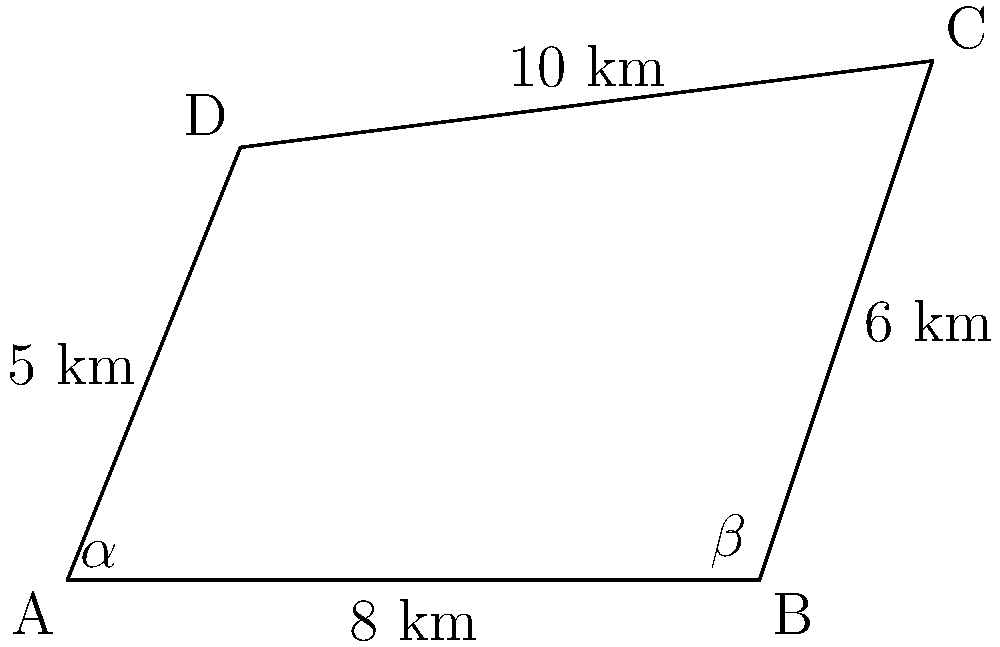Imagine you're scouting locations for the next big Irish drama series, and you've found a perfect field for a crucial scene. The field is shaped like an irregular quadrilateral ABCD, as shown in the diagram. The lengths of the sides are: AB = 8 km, BC = 6 km, CD = 10 km, and DA = 5 km. The angles at vertices A and B are $\alpha$ and $\beta$ respectively. If $\alpha = 60°$ and $\beta = 120°$, what is the area of the field in square kilometers? Let's solve this step-by-step using trigonometric formulas:

1) We can divide the quadrilateral into two triangles: ABC and ACD.

2) For triangle ABC:
   - We know two sides (AB = 8 km, BC = 6 km) and the included angle ($\beta = 120°$).
   - Area of ABC = $\frac{1}{2} \cdot AB \cdot BC \cdot \sin(\beta)$
   - Area of ABC = $\frac{1}{2} \cdot 8 \cdot 6 \cdot \sin(120°) = 24 \cdot \frac{\sqrt{3}}{2} = 12\sqrt{3}$ km²

3) For triangle ACD:
   - We know two sides (CD = 10 km, DA = 5 km) and the angle at A ($\alpha = 60°$).
   - Area of ACD = $\frac{1}{2} \cdot CD \cdot DA \cdot \sin(\alpha)$
   - Area of ACD = $\frac{1}{2} \cdot 10 \cdot 5 \cdot \sin(60°) = 25 \cdot \frac{\sqrt{3}}{2} = \frac{25\sqrt{3}}{2}$ km²

4) The total area of the quadrilateral is the sum of these two triangles:
   Total Area = Area of ABC + Area of ACD
               = $12\sqrt{3} + \frac{25\sqrt{3}}{2}$
               = $24\sqrt{3} + 25\sqrt{3}$
               = $49\sqrt{3}$
               = $49\sqrt{3}$ km²

Therefore, the area of the field is $49\sqrt{3}$ square kilometers.
Answer: $49\sqrt{3}$ km² 